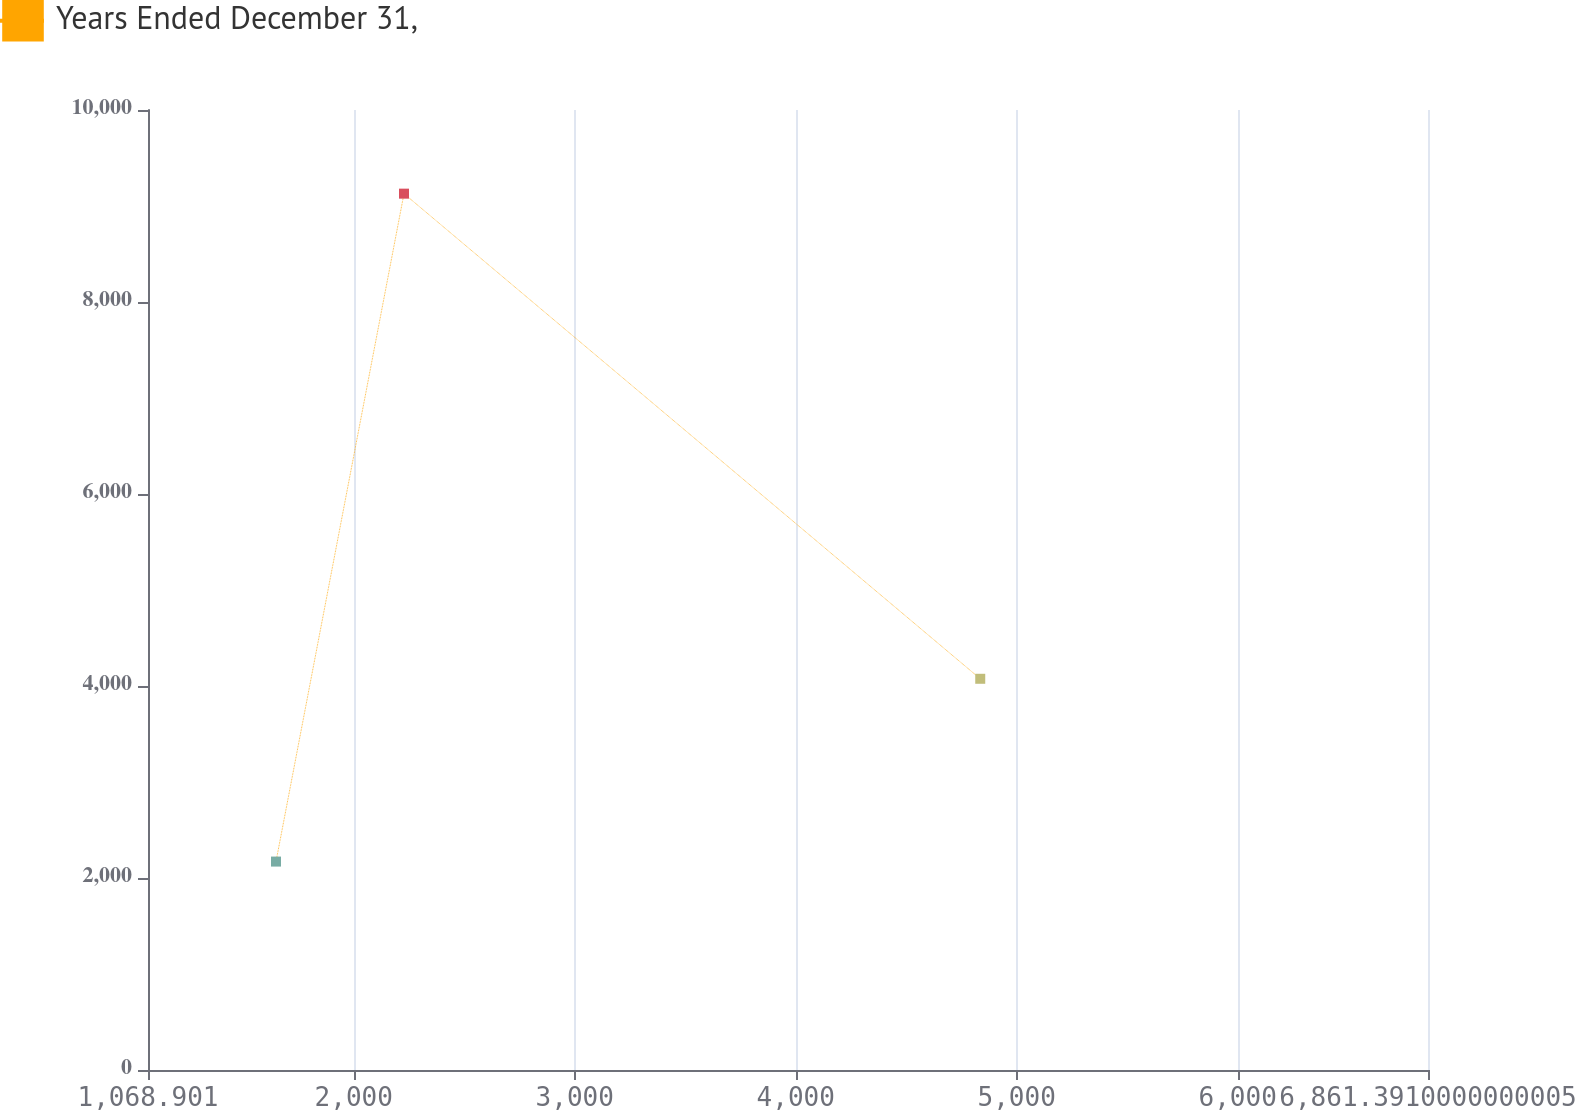Convert chart to OTSL. <chart><loc_0><loc_0><loc_500><loc_500><line_chart><ecel><fcel>Years Ended December 31,<nl><fcel>1648.15<fcel>2171.1<nl><fcel>2227.4<fcel>9128.6<nl><fcel>4835.11<fcel>4075.17<nl><fcel>7440.64<fcel>1139.72<nl></chart> 